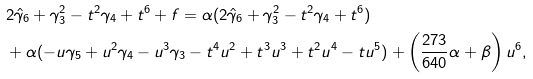<formula> <loc_0><loc_0><loc_500><loc_500>& 2 \hat { \gamma } _ { 6 } + \gamma _ { 3 } ^ { 2 } - t ^ { 2 } \gamma _ { 4 } + t ^ { 6 } + f = \alpha ( 2 \hat { \gamma } _ { 6 } + \gamma _ { 3 } ^ { 2 } - t ^ { 2 } \gamma _ { 4 } + t ^ { 6 } ) \\ & + \alpha ( - u \gamma _ { 5 } + u ^ { 2 } \gamma _ { 4 } - u ^ { 3 } \gamma _ { 3 } - t ^ { 4 } u ^ { 2 } + t ^ { 3 } u ^ { 3 } + t ^ { 2 } u ^ { 4 } - t u ^ { 5 } ) + \left ( \frac { 2 7 3 } { 6 4 0 } \alpha + \beta \right ) u ^ { 6 } ,</formula> 